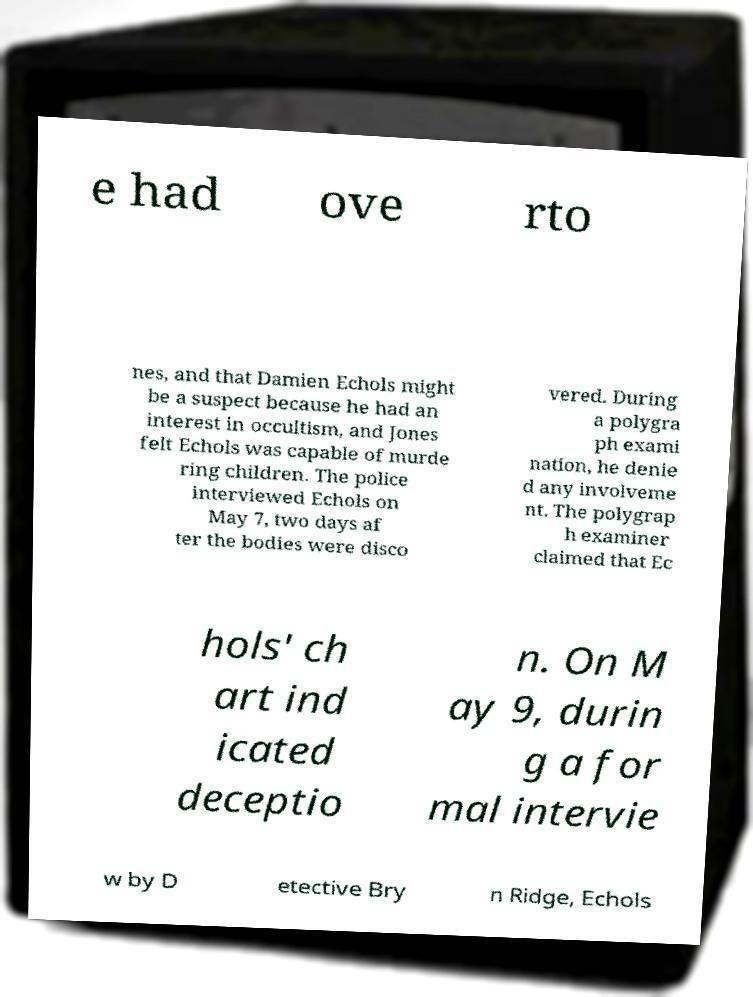Please identify and transcribe the text found in this image. e had ove rto nes, and that Damien Echols might be a suspect because he had an interest in occultism, and Jones felt Echols was capable of murde ring children. The police interviewed Echols on May 7, two days af ter the bodies were disco vered. During a polygra ph exami nation, he denie d any involveme nt. The polygrap h examiner claimed that Ec hols' ch art ind icated deceptio n. On M ay 9, durin g a for mal intervie w by D etective Bry n Ridge, Echols 